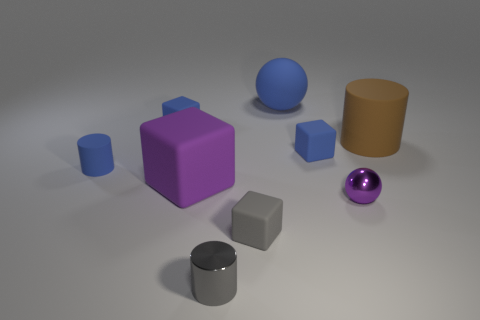There is a small metal cylinder; how many blue matte objects are right of it?
Your answer should be very brief. 2. There is a ball in front of the rubber cylinder that is to the right of the small cylinder right of the small matte cylinder; what color is it?
Provide a succinct answer. Purple. Do the rubber cylinder that is to the left of the big brown matte object and the tiny cylinder in front of the tiny gray rubber object have the same color?
Provide a short and direct response. No. What is the shape of the tiny object that is behind the thing that is to the right of the small purple metal thing?
Your answer should be very brief. Cube. Are there any brown cylinders that have the same size as the brown matte thing?
Your response must be concise. No. What number of other things have the same shape as the large brown object?
Your answer should be very brief. 2. Are there the same number of matte blocks that are in front of the gray block and tiny shiny cylinders that are right of the purple sphere?
Keep it short and to the point. Yes. Are any small blue cylinders visible?
Give a very brief answer. Yes. There is a matte object that is in front of the big matte object in front of the big cylinder that is right of the tiny gray cylinder; what size is it?
Keep it short and to the point. Small. The gray metal object that is the same size as the gray rubber thing is what shape?
Your response must be concise. Cylinder. 